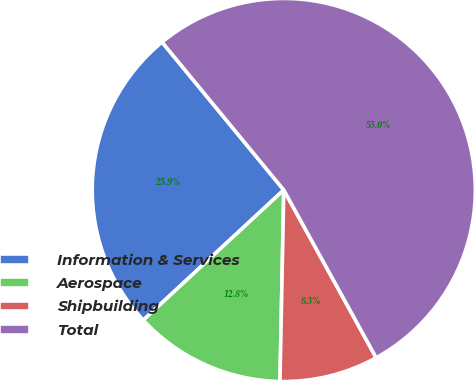Convert chart. <chart><loc_0><loc_0><loc_500><loc_500><pie_chart><fcel>Information & Services<fcel>Aerospace<fcel>Shipbuilding<fcel>Total<nl><fcel>25.93%<fcel>12.79%<fcel>8.33%<fcel>52.95%<nl></chart> 